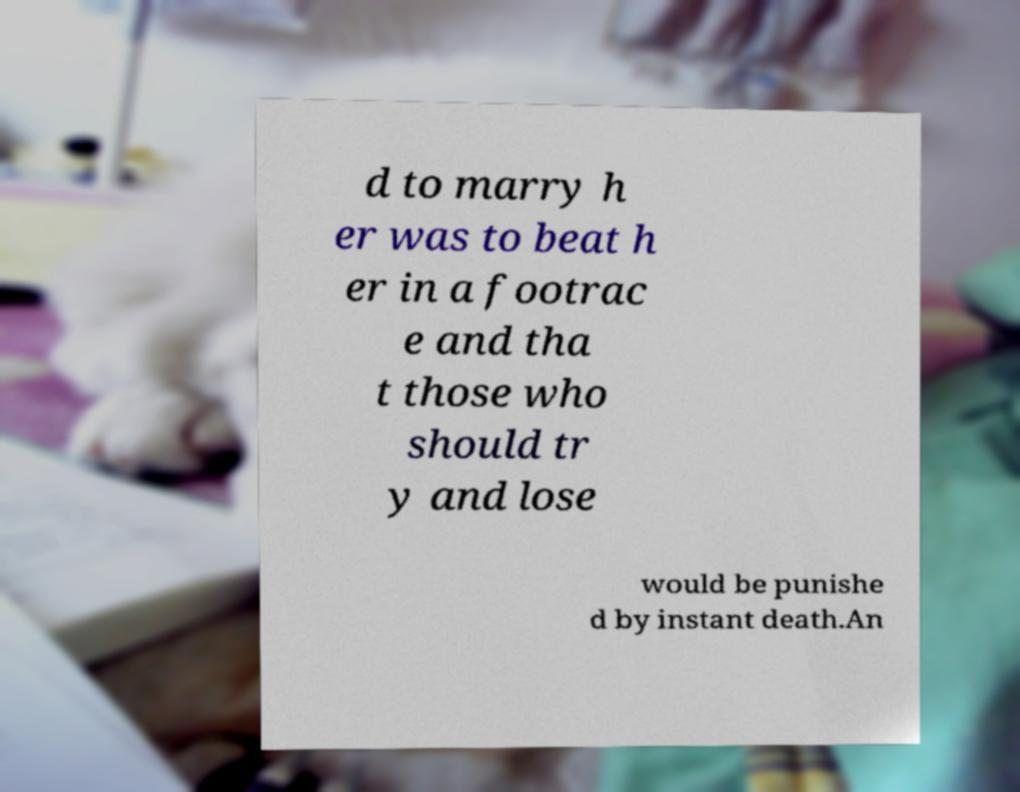Could you extract and type out the text from this image? d to marry h er was to beat h er in a footrac e and tha t those who should tr y and lose would be punishe d by instant death.An 